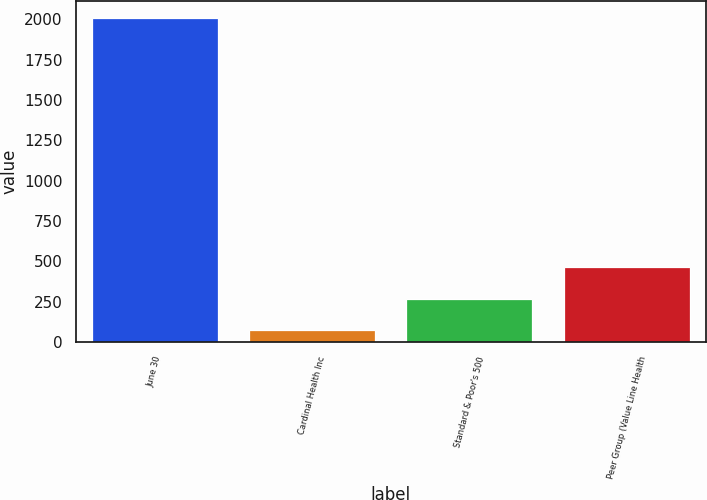<chart> <loc_0><loc_0><loc_500><loc_500><bar_chart><fcel>June 30<fcel>Cardinal Health Inc<fcel>Standard & Poor's 500<fcel>Peer Group (Value Line Health<nl><fcel>2010<fcel>76.82<fcel>270.14<fcel>463.46<nl></chart> 